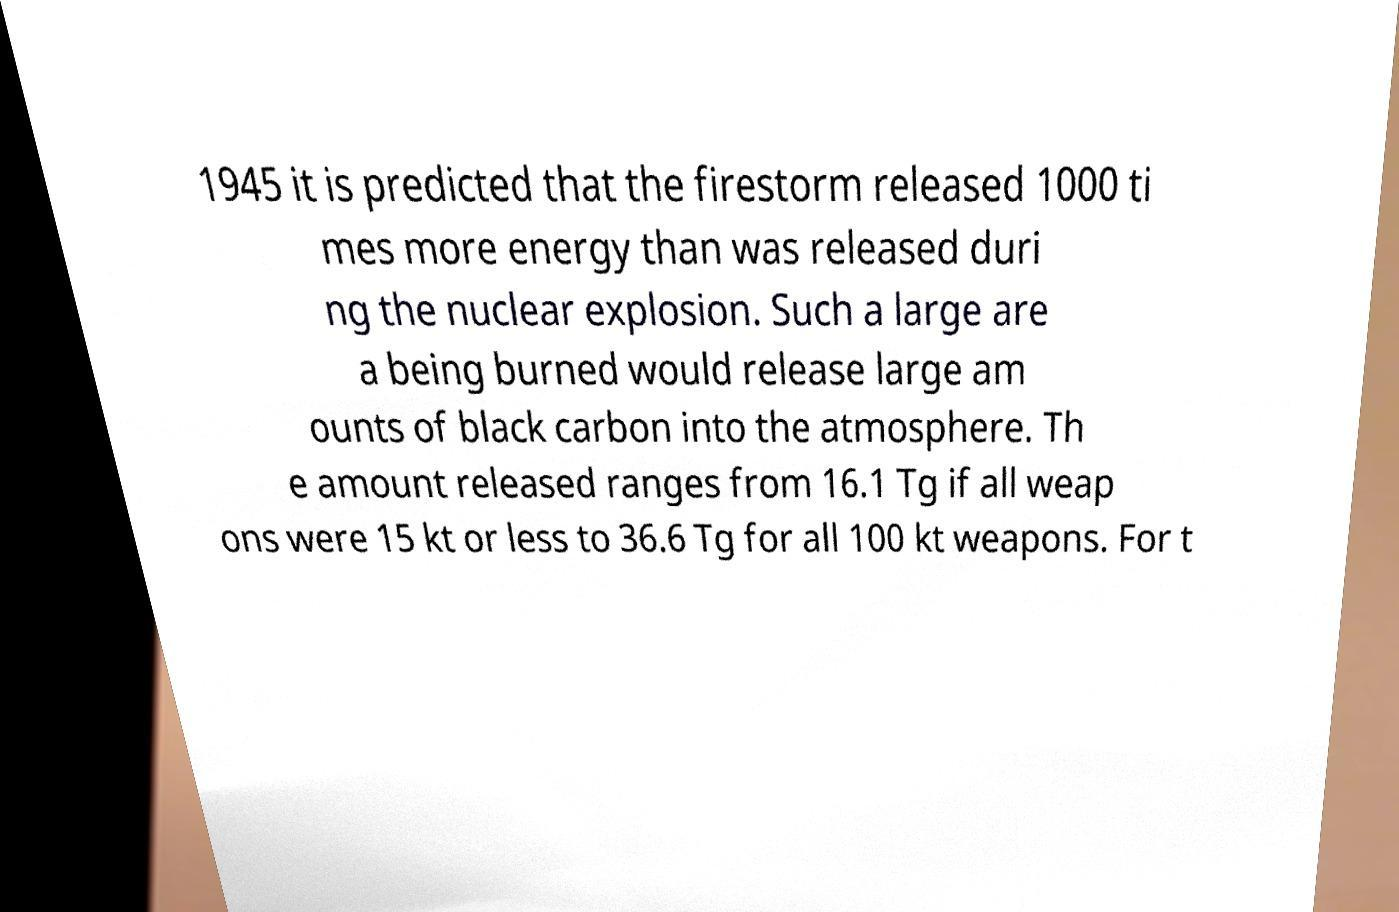There's text embedded in this image that I need extracted. Can you transcribe it verbatim? 1945 it is predicted that the firestorm released 1000 ti mes more energy than was released duri ng the nuclear explosion. Such a large are a being burned would release large am ounts of black carbon into the atmosphere. Th e amount released ranges from 16.1 Tg if all weap ons were 15 kt or less to 36.6 Tg for all 100 kt weapons. For t 